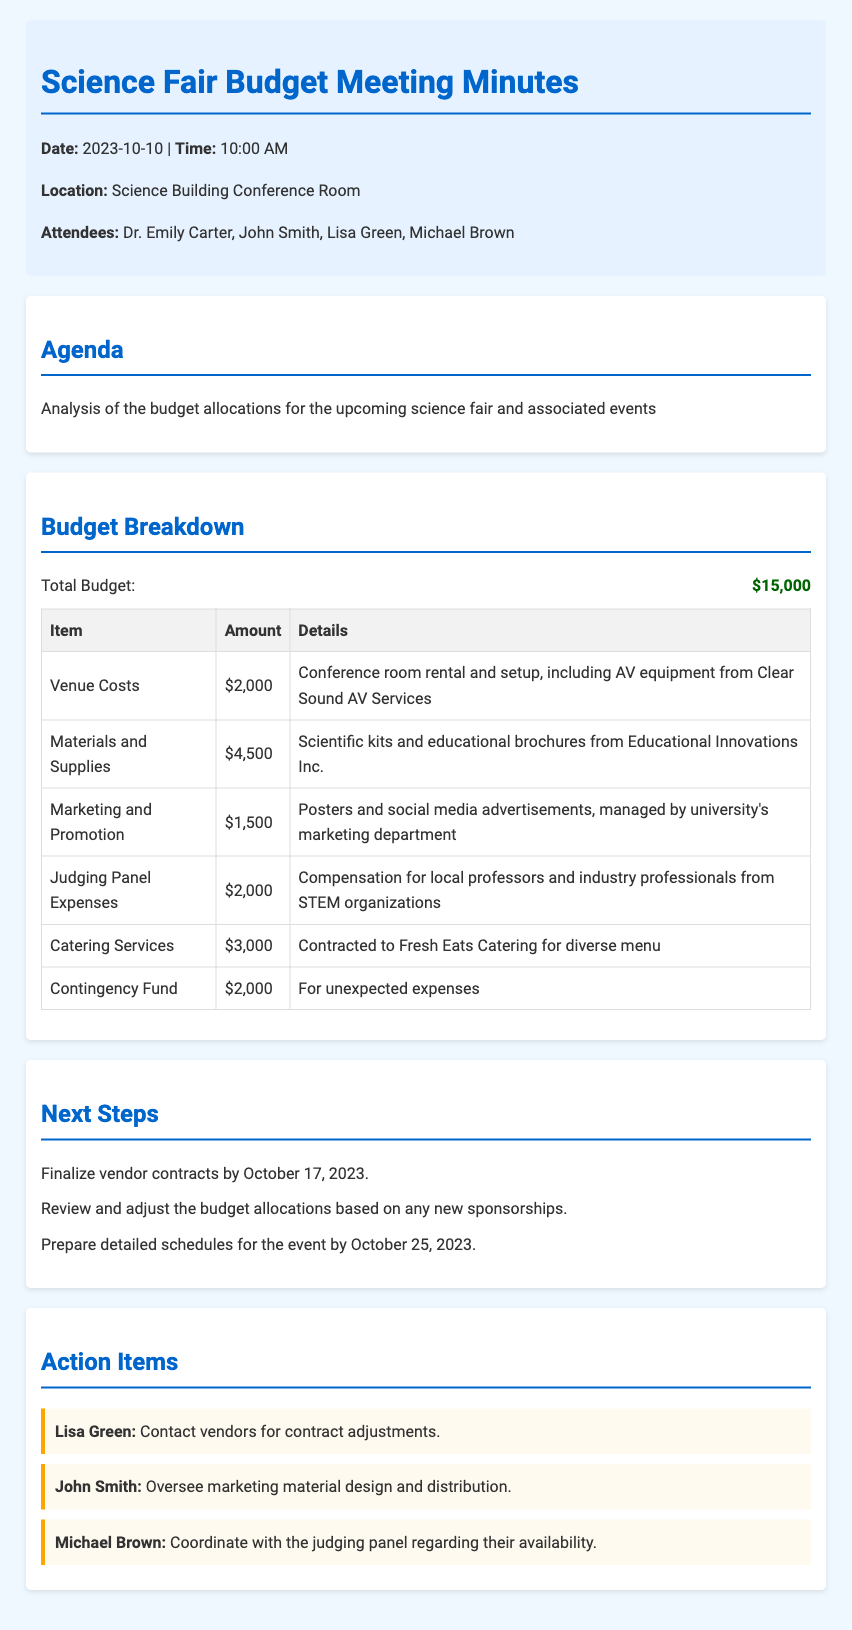What is the total budget? The total budget is specified in the document, stating $15,000 as the total amount allocated.
Answer: $15,000 What is the amount allocated for materials and supplies? The document lists the amount allocated for materials and supplies, which is $4,500.
Answer: $4,500 Who is responsible for overseeing marketing material design? The action item mentions John Smith as the individual overseeing the marketing material design.
Answer: John Smith What is the deadline to finalize vendor contracts? The next steps section specifies October 17, 2023, as the deadline for finalizing vendor contracts.
Answer: October 17, 2023 How much is allocated for catering services? The document specifies that $3,000 is allocated for catering services.
Answer: $3,000 What is the budget item for unexpected expenses called? The document identifies the budget item for unexpected expenses as the contingency fund.
Answer: Contingency Fund What type of items are included in the budget breakdown? The budget breakdown includes items such as venue costs, materials and supplies, and marketing and promotion.
Answer: Venue costs, materials and supplies, marketing and promotion How many attendees were present at the meeting? The document lists four attendees present at the meeting.
Answer: Four attendees 